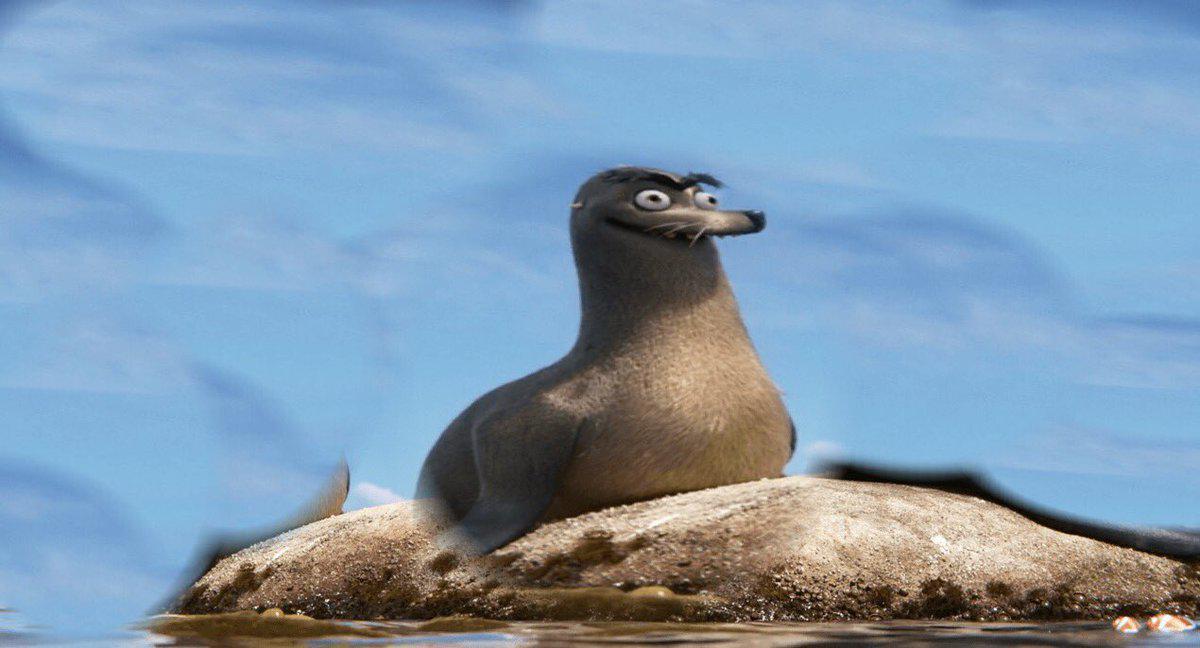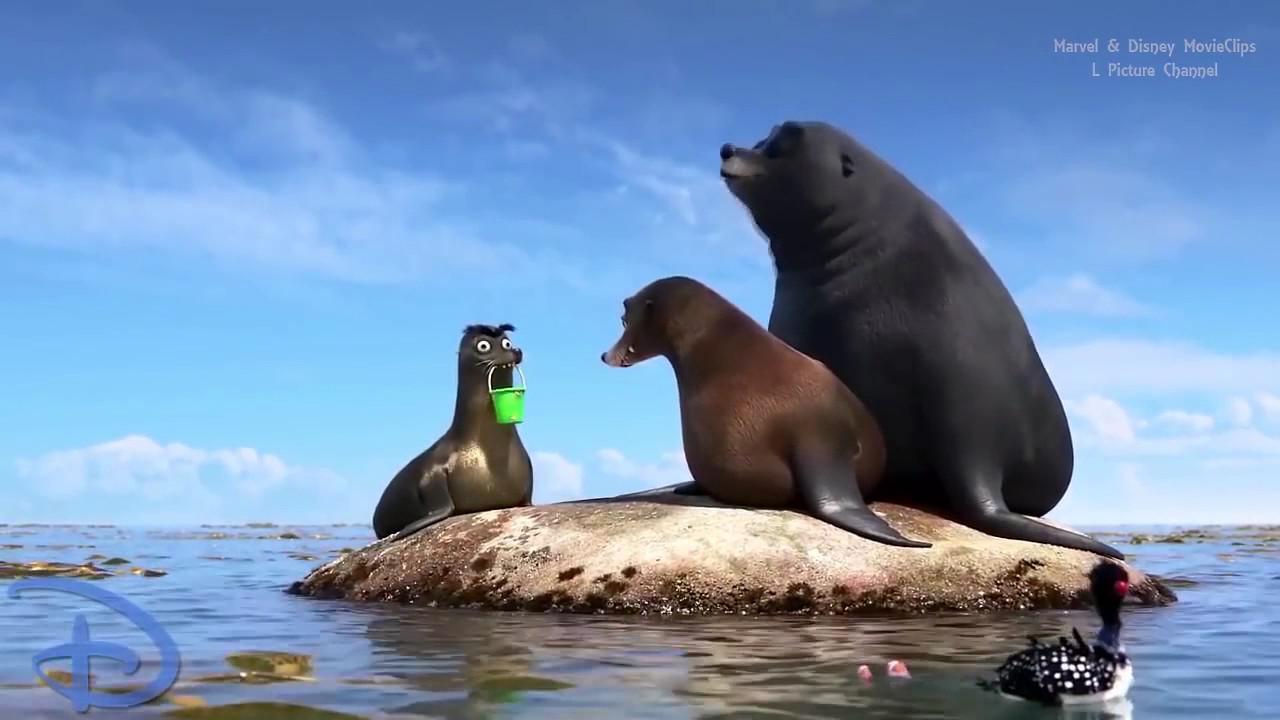The first image is the image on the left, the second image is the image on the right. For the images displayed, is the sentence "Four animals are sitting on rocks near the water." factually correct? Answer yes or no. Yes. The first image is the image on the left, the second image is the image on the right. Assess this claim about the two images: "An image includes a large seal with wide-open mouth and a smaller seal with a closed mouth.". Correct or not? Answer yes or no. No. 